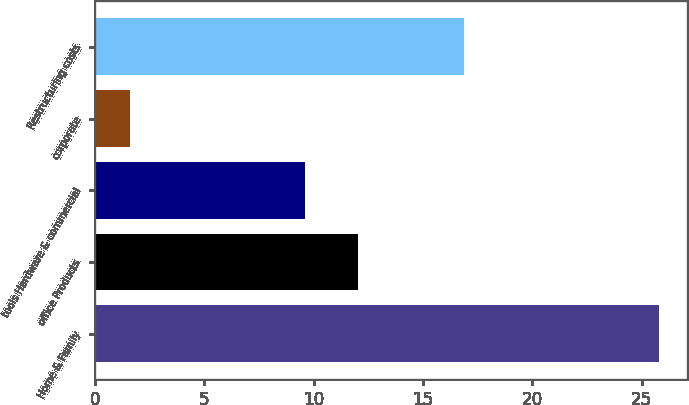Convert chart to OTSL. <chart><loc_0><loc_0><loc_500><loc_500><bar_chart><fcel>Home & Family<fcel>office Products<fcel>tools Hardware & commercial<fcel>corporate<fcel>Restructuring costs<nl><fcel>25.8<fcel>12.02<fcel>9.6<fcel>1.6<fcel>16.9<nl></chart> 